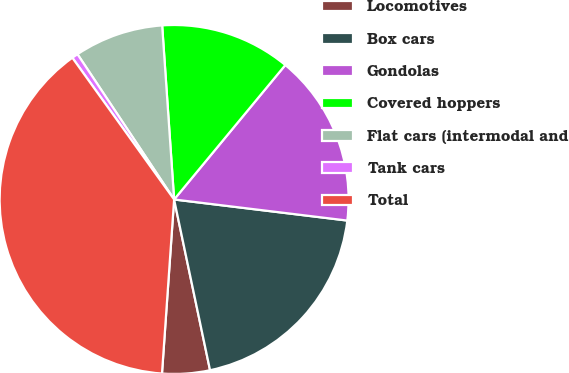Convert chart. <chart><loc_0><loc_0><loc_500><loc_500><pie_chart><fcel>Locomotives<fcel>Box cars<fcel>Gondolas<fcel>Covered hoppers<fcel>Flat cars (intermodal and<fcel>Tank cars<fcel>Total<nl><fcel>4.41%<fcel>19.77%<fcel>15.93%<fcel>12.09%<fcel>8.25%<fcel>0.57%<fcel>38.98%<nl></chart> 